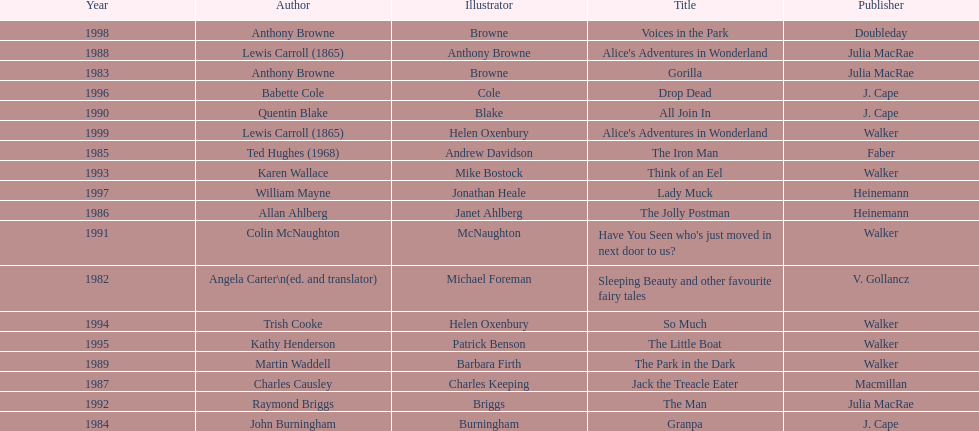Which author wrote the first award winner? Angela Carter. 